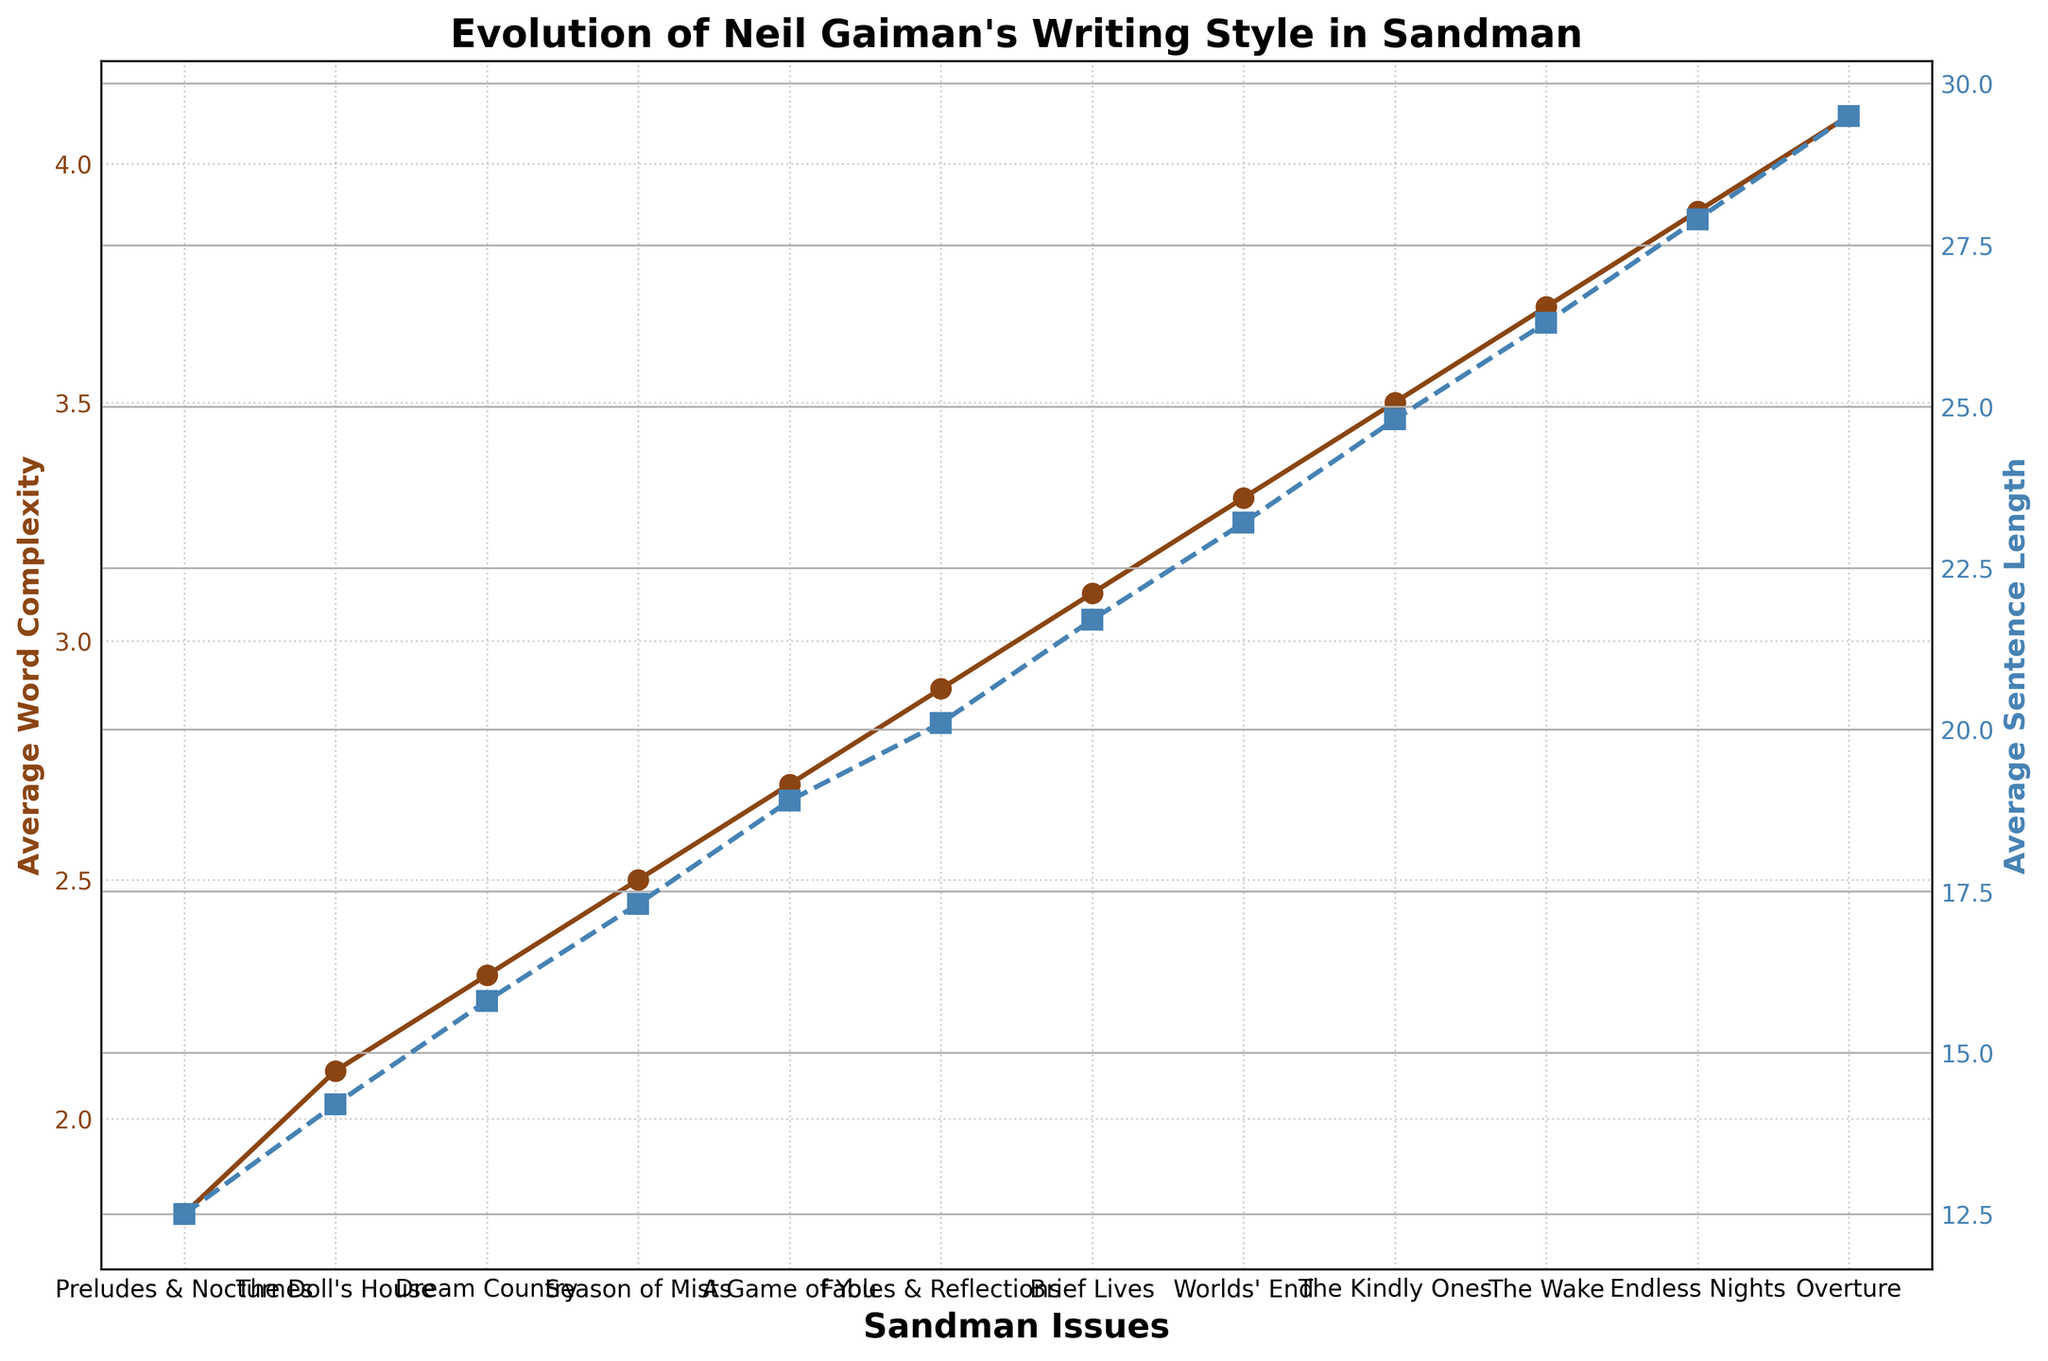What is the difference in the average word complexity from "Preludes & Nocturnes" to "Overture"? "Preludes & Nocturnes" has an average word complexity of 1.8, and "Overture" has an average word complexity of 4.1. The difference is calculated as 4.1 - 1.8.
Answer: 2.3 Which issue has the highest average sentence length? By looking at the second y-axis (average sentence length) and following the highest point on the line graph, "Overture" has the highest average sentence length.
Answer: Overture How does the average word complexity in "The Wake" compare to that in "Season of Mists"? "The Wake" has an average word complexity of 3.7, whereas "Season of Mists" has an average word complexity of 2.5. 3.7 is greater than 2.5.
Answer: The Wake has higher complexity Between "Fables & Reflections" and "Worlds' End," which issue shows a greater increase in average sentence length compared to the previous issue? "Fables & Reflections" follows "A Game of You" and the increase in sentence length is from 18.9 to 20.1, a difference of 1.2. "Worlds' End" follows "Brief Lives" and the increase in sentence length is from 21.7 to 23.2, a difference of 1.5. "Worlds' End" shows a greater increase.
Answer: Worlds' End Calculate the average of average sentence lengths from "Preludes & Nocturnes" to "A Game of You." Summing the average sentence lengths: 12.5 + 14.2 + 15.8 + 17.3 + 18.9 = 78.7. There are 5 data points, so the average = 78.7 / 5 = 15.74.
Answer: 15.74 What is the total increase in average sentence length across the entire series from "Preludes & Nocturnes" to "Overture"? The average sentence length starts at 12.5 in "Preludes & Nocturnes" and ends at 29.5 in "Overture." The total increase is 29.5 - 12.5.
Answer: 17 Which issue shows the first instance where the average word complexity surpasses 3.0? Following the line for average word complexity, "Brief Lives" is the first issue to surpass 3.0.
Answer: Brief Lives Is the rate of increase in average sentence length steeper between "The Kindly Ones" and "The Wake" or between "The Wake" and "Endless Nights"? From "The Kindly Ones" to "The Wake," the increase is from 24.8 to 26.3 (1.5 units). From "The Wake" to "Endless Nights," the increase is from 26.3 to 27.9 (1.6 units). The increase between "The Wake" and "Endless Nights" is steeper.
Answer: The Wake to Endless Nights 